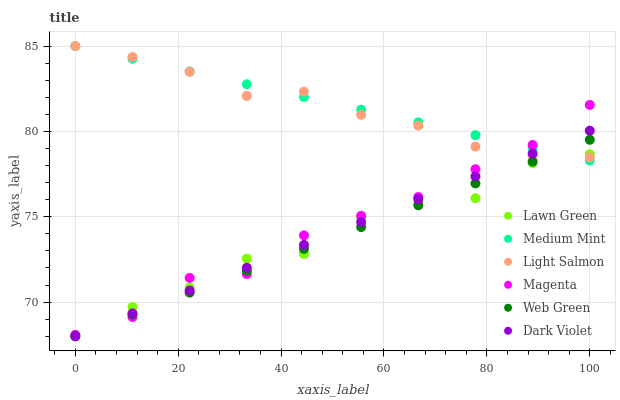Does Web Green have the minimum area under the curve?
Answer yes or no. Yes. Does Medium Mint have the maximum area under the curve?
Answer yes or no. Yes. Does Lawn Green have the minimum area under the curve?
Answer yes or no. No. Does Lawn Green have the maximum area under the curve?
Answer yes or no. No. Is Medium Mint the smoothest?
Answer yes or no. Yes. Is Lawn Green the roughest?
Answer yes or no. Yes. Is Light Salmon the smoothest?
Answer yes or no. No. Is Light Salmon the roughest?
Answer yes or no. No. Does Lawn Green have the lowest value?
Answer yes or no. Yes. Does Light Salmon have the lowest value?
Answer yes or no. No. Does Light Salmon have the highest value?
Answer yes or no. Yes. Does Lawn Green have the highest value?
Answer yes or no. No. Does Medium Mint intersect Web Green?
Answer yes or no. Yes. Is Medium Mint less than Web Green?
Answer yes or no. No. Is Medium Mint greater than Web Green?
Answer yes or no. No. 